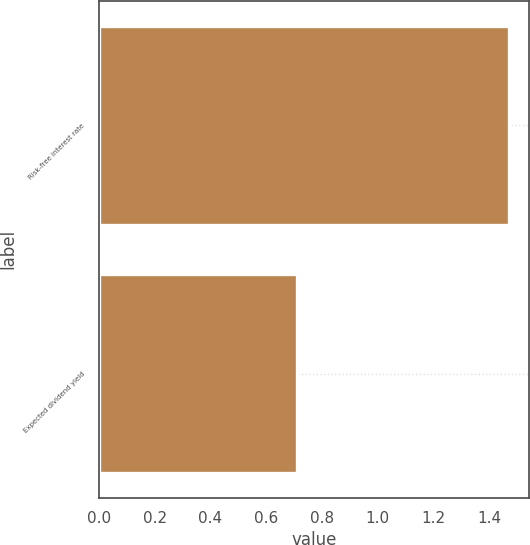Convert chart to OTSL. <chart><loc_0><loc_0><loc_500><loc_500><bar_chart><fcel>Risk-free interest rate<fcel>Expected dividend yield<nl><fcel>1.47<fcel>0.71<nl></chart> 